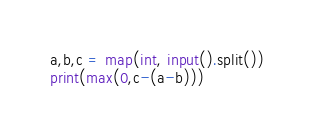<code> <loc_0><loc_0><loc_500><loc_500><_Python_>a,b,c = map(int, input().split())
print(max(0,c-(a-b)))</code> 